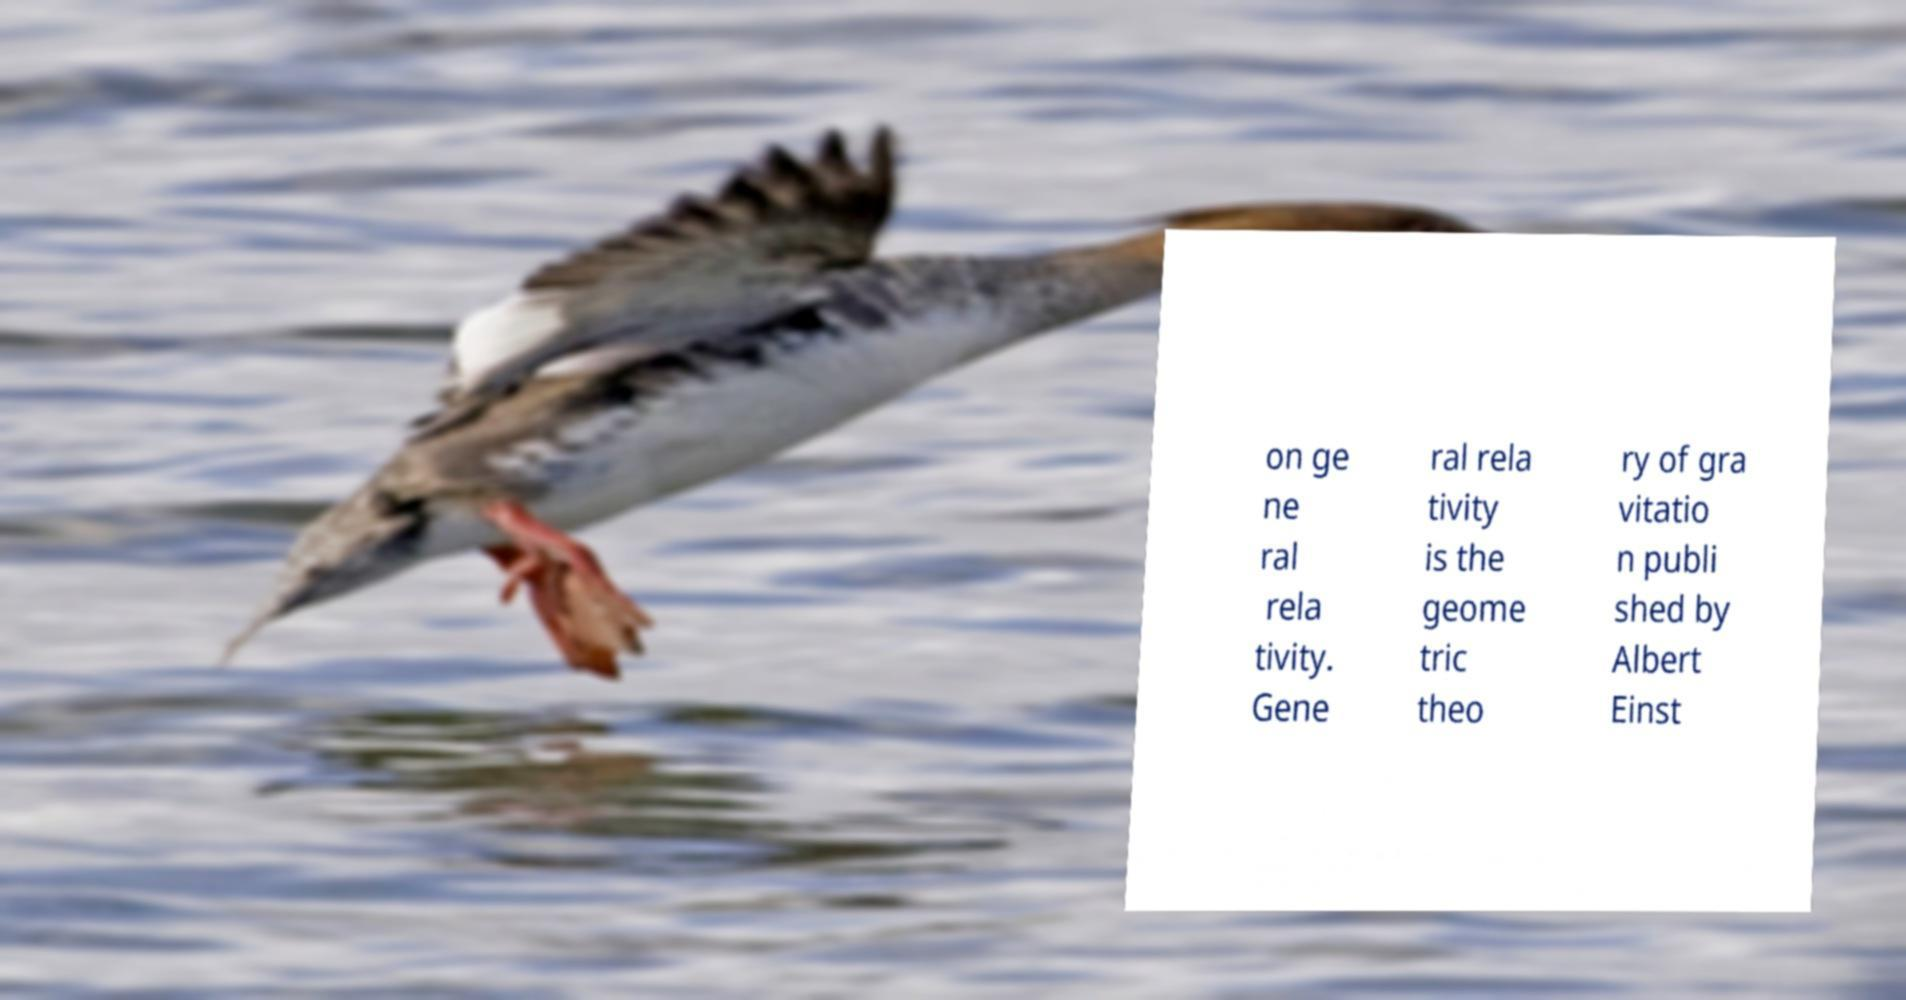Could you assist in decoding the text presented in this image and type it out clearly? on ge ne ral rela tivity. Gene ral rela tivity is the geome tric theo ry of gra vitatio n publi shed by Albert Einst 